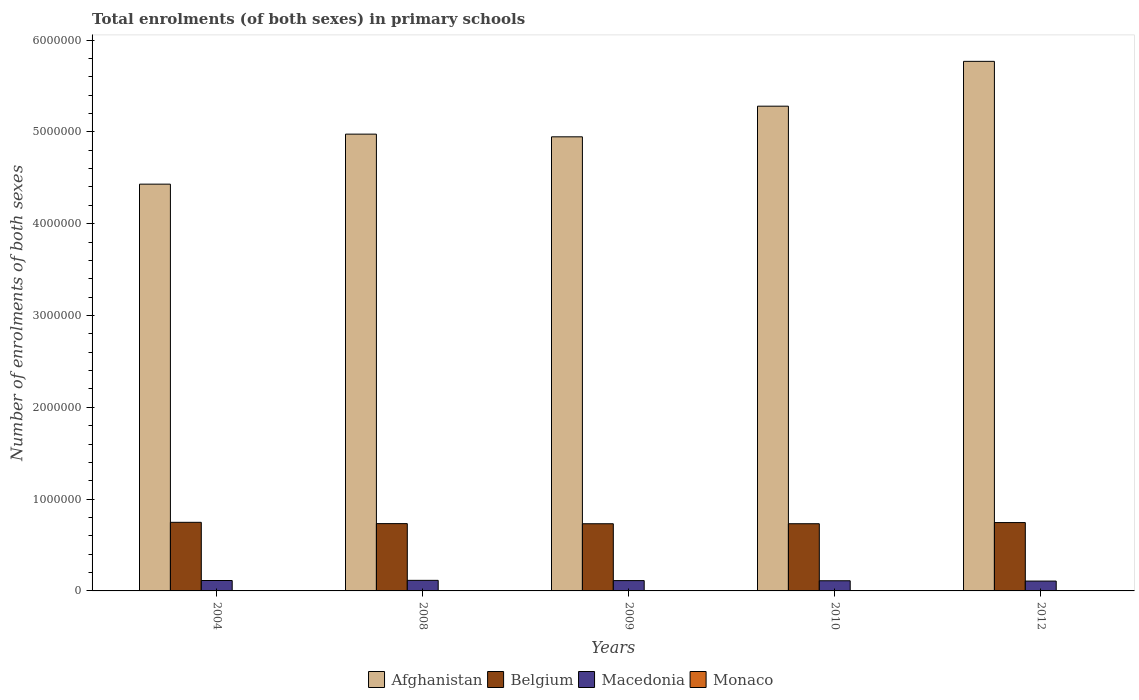How many different coloured bars are there?
Keep it short and to the point. 4. Are the number of bars per tick equal to the number of legend labels?
Provide a short and direct response. Yes. In how many cases, is the number of bars for a given year not equal to the number of legend labels?
Keep it short and to the point. 0. What is the number of enrolments in primary schools in Afghanistan in 2009?
Ensure brevity in your answer.  4.95e+06. Across all years, what is the maximum number of enrolments in primary schools in Afghanistan?
Give a very brief answer. 5.77e+06. Across all years, what is the minimum number of enrolments in primary schools in Belgium?
Offer a very short reply. 7.32e+05. In which year was the number of enrolments in primary schools in Belgium maximum?
Offer a terse response. 2004. What is the total number of enrolments in primary schools in Belgium in the graph?
Your response must be concise. 3.69e+06. What is the difference between the number of enrolments in primary schools in Monaco in 2004 and that in 2012?
Make the answer very short. 65. What is the difference between the number of enrolments in primary schools in Afghanistan in 2009 and the number of enrolments in primary schools in Monaco in 2004?
Offer a terse response. 4.94e+06. What is the average number of enrolments in primary schools in Monaco per year?
Ensure brevity in your answer.  1821.2. In the year 2009, what is the difference between the number of enrolments in primary schools in Monaco and number of enrolments in primary schools in Afghanistan?
Offer a very short reply. -4.94e+06. In how many years, is the number of enrolments in primary schools in Afghanistan greater than 2200000?
Make the answer very short. 5. What is the ratio of the number of enrolments in primary schools in Belgium in 2008 to that in 2009?
Provide a succinct answer. 1. Is the difference between the number of enrolments in primary schools in Monaco in 2008 and 2012 greater than the difference between the number of enrolments in primary schools in Afghanistan in 2008 and 2012?
Your response must be concise. Yes. What is the difference between the highest and the second highest number of enrolments in primary schools in Macedonia?
Make the answer very short. 1720. What is the difference between the highest and the lowest number of enrolments in primary schools in Belgium?
Your response must be concise. 1.55e+04. Is the sum of the number of enrolments in primary schools in Macedonia in 2009 and 2012 greater than the maximum number of enrolments in primary schools in Belgium across all years?
Keep it short and to the point. No. Is it the case that in every year, the sum of the number of enrolments in primary schools in Afghanistan and number of enrolments in primary schools in Belgium is greater than the sum of number of enrolments in primary schools in Macedonia and number of enrolments in primary schools in Monaco?
Offer a terse response. No. What does the 2nd bar from the left in 2009 represents?
Provide a short and direct response. Belgium. What does the 1st bar from the right in 2008 represents?
Provide a short and direct response. Monaco. How many years are there in the graph?
Provide a succinct answer. 5. Are the values on the major ticks of Y-axis written in scientific E-notation?
Provide a succinct answer. No. What is the title of the graph?
Make the answer very short. Total enrolments (of both sexes) in primary schools. What is the label or title of the Y-axis?
Offer a very short reply. Number of enrolments of both sexes. What is the Number of enrolments of both sexes in Afghanistan in 2004?
Your response must be concise. 4.43e+06. What is the Number of enrolments of both sexes in Belgium in 2004?
Your response must be concise. 7.47e+05. What is the Number of enrolments of both sexes of Macedonia in 2004?
Make the answer very short. 1.13e+05. What is the Number of enrolments of both sexes in Monaco in 2004?
Provide a succinct answer. 1831. What is the Number of enrolments of both sexes in Afghanistan in 2008?
Your answer should be compact. 4.97e+06. What is the Number of enrolments of both sexes in Belgium in 2008?
Your answer should be compact. 7.33e+05. What is the Number of enrolments of both sexes in Macedonia in 2008?
Offer a terse response. 1.15e+05. What is the Number of enrolments of both sexes in Monaco in 2008?
Make the answer very short. 1852. What is the Number of enrolments of both sexes of Afghanistan in 2009?
Your answer should be compact. 4.95e+06. What is the Number of enrolments of both sexes in Belgium in 2009?
Make the answer very short. 7.32e+05. What is the Number of enrolments of both sexes in Macedonia in 2009?
Keep it short and to the point. 1.12e+05. What is the Number of enrolments of both sexes of Monaco in 2009?
Offer a terse response. 1837. What is the Number of enrolments of both sexes of Afghanistan in 2010?
Ensure brevity in your answer.  5.28e+06. What is the Number of enrolments of both sexes of Belgium in 2010?
Give a very brief answer. 7.32e+05. What is the Number of enrolments of both sexes of Macedonia in 2010?
Your answer should be compact. 1.11e+05. What is the Number of enrolments of both sexes in Monaco in 2010?
Keep it short and to the point. 1820. What is the Number of enrolments of both sexes of Afghanistan in 2012?
Keep it short and to the point. 5.77e+06. What is the Number of enrolments of both sexes of Belgium in 2012?
Provide a succinct answer. 7.44e+05. What is the Number of enrolments of both sexes of Macedonia in 2012?
Offer a terse response. 1.07e+05. What is the Number of enrolments of both sexes of Monaco in 2012?
Ensure brevity in your answer.  1766. Across all years, what is the maximum Number of enrolments of both sexes of Afghanistan?
Ensure brevity in your answer.  5.77e+06. Across all years, what is the maximum Number of enrolments of both sexes in Belgium?
Provide a short and direct response. 7.47e+05. Across all years, what is the maximum Number of enrolments of both sexes in Macedonia?
Offer a very short reply. 1.15e+05. Across all years, what is the maximum Number of enrolments of both sexes in Monaco?
Your answer should be compact. 1852. Across all years, what is the minimum Number of enrolments of both sexes of Afghanistan?
Your response must be concise. 4.43e+06. Across all years, what is the minimum Number of enrolments of both sexes in Belgium?
Your answer should be compact. 7.32e+05. Across all years, what is the minimum Number of enrolments of both sexes in Macedonia?
Your answer should be compact. 1.07e+05. Across all years, what is the minimum Number of enrolments of both sexes in Monaco?
Offer a terse response. 1766. What is the total Number of enrolments of both sexes of Afghanistan in the graph?
Provide a succinct answer. 2.54e+07. What is the total Number of enrolments of both sexes in Belgium in the graph?
Provide a short and direct response. 3.69e+06. What is the total Number of enrolments of both sexes of Macedonia in the graph?
Offer a terse response. 5.59e+05. What is the total Number of enrolments of both sexes of Monaco in the graph?
Provide a short and direct response. 9106. What is the difference between the Number of enrolments of both sexes of Afghanistan in 2004 and that in 2008?
Make the answer very short. -5.45e+05. What is the difference between the Number of enrolments of both sexes in Belgium in 2004 and that in 2008?
Make the answer very short. 1.41e+04. What is the difference between the Number of enrolments of both sexes of Macedonia in 2004 and that in 2008?
Make the answer very short. -1720. What is the difference between the Number of enrolments of both sexes of Monaco in 2004 and that in 2008?
Your answer should be compact. -21. What is the difference between the Number of enrolments of both sexes of Afghanistan in 2004 and that in 2009?
Ensure brevity in your answer.  -5.15e+05. What is the difference between the Number of enrolments of both sexes of Belgium in 2004 and that in 2009?
Make the answer very short. 1.55e+04. What is the difference between the Number of enrolments of both sexes in Macedonia in 2004 and that in 2009?
Your answer should be compact. 885. What is the difference between the Number of enrolments of both sexes of Afghanistan in 2004 and that in 2010?
Provide a succinct answer. -8.49e+05. What is the difference between the Number of enrolments of both sexes in Belgium in 2004 and that in 2010?
Offer a very short reply. 1.54e+04. What is the difference between the Number of enrolments of both sexes of Macedonia in 2004 and that in 2010?
Give a very brief answer. 2603. What is the difference between the Number of enrolments of both sexes of Monaco in 2004 and that in 2010?
Offer a terse response. 11. What is the difference between the Number of enrolments of both sexes of Afghanistan in 2004 and that in 2012?
Your response must be concise. -1.34e+06. What is the difference between the Number of enrolments of both sexes in Belgium in 2004 and that in 2012?
Give a very brief answer. 2780. What is the difference between the Number of enrolments of both sexes in Macedonia in 2004 and that in 2012?
Give a very brief answer. 6084. What is the difference between the Number of enrolments of both sexes of Monaco in 2004 and that in 2012?
Your answer should be very brief. 65. What is the difference between the Number of enrolments of both sexes in Afghanistan in 2008 and that in 2009?
Your response must be concise. 2.92e+04. What is the difference between the Number of enrolments of both sexes of Belgium in 2008 and that in 2009?
Give a very brief answer. 1449. What is the difference between the Number of enrolments of both sexes of Macedonia in 2008 and that in 2009?
Make the answer very short. 2605. What is the difference between the Number of enrolments of both sexes of Monaco in 2008 and that in 2009?
Make the answer very short. 15. What is the difference between the Number of enrolments of both sexes in Afghanistan in 2008 and that in 2010?
Your response must be concise. -3.04e+05. What is the difference between the Number of enrolments of both sexes of Belgium in 2008 and that in 2010?
Make the answer very short. 1291. What is the difference between the Number of enrolments of both sexes of Macedonia in 2008 and that in 2010?
Your response must be concise. 4323. What is the difference between the Number of enrolments of both sexes of Monaco in 2008 and that in 2010?
Make the answer very short. 32. What is the difference between the Number of enrolments of both sexes of Afghanistan in 2008 and that in 2012?
Keep it short and to the point. -7.93e+05. What is the difference between the Number of enrolments of both sexes in Belgium in 2008 and that in 2012?
Your answer should be very brief. -1.13e+04. What is the difference between the Number of enrolments of both sexes of Macedonia in 2008 and that in 2012?
Your answer should be compact. 7804. What is the difference between the Number of enrolments of both sexes of Monaco in 2008 and that in 2012?
Make the answer very short. 86. What is the difference between the Number of enrolments of both sexes of Afghanistan in 2009 and that in 2010?
Keep it short and to the point. -3.34e+05. What is the difference between the Number of enrolments of both sexes of Belgium in 2009 and that in 2010?
Your response must be concise. -158. What is the difference between the Number of enrolments of both sexes in Macedonia in 2009 and that in 2010?
Offer a very short reply. 1718. What is the difference between the Number of enrolments of both sexes of Afghanistan in 2009 and that in 2012?
Your response must be concise. -8.22e+05. What is the difference between the Number of enrolments of both sexes of Belgium in 2009 and that in 2012?
Your response must be concise. -1.27e+04. What is the difference between the Number of enrolments of both sexes of Macedonia in 2009 and that in 2012?
Offer a very short reply. 5199. What is the difference between the Number of enrolments of both sexes of Afghanistan in 2010 and that in 2012?
Offer a very short reply. -4.88e+05. What is the difference between the Number of enrolments of both sexes in Belgium in 2010 and that in 2012?
Your answer should be compact. -1.26e+04. What is the difference between the Number of enrolments of both sexes of Macedonia in 2010 and that in 2012?
Your response must be concise. 3481. What is the difference between the Number of enrolments of both sexes of Monaco in 2010 and that in 2012?
Your answer should be compact. 54. What is the difference between the Number of enrolments of both sexes of Afghanistan in 2004 and the Number of enrolments of both sexes of Belgium in 2008?
Offer a terse response. 3.70e+06. What is the difference between the Number of enrolments of both sexes of Afghanistan in 2004 and the Number of enrolments of both sexes of Macedonia in 2008?
Keep it short and to the point. 4.32e+06. What is the difference between the Number of enrolments of both sexes of Afghanistan in 2004 and the Number of enrolments of both sexes of Monaco in 2008?
Your answer should be very brief. 4.43e+06. What is the difference between the Number of enrolments of both sexes of Belgium in 2004 and the Number of enrolments of both sexes of Macedonia in 2008?
Provide a short and direct response. 6.32e+05. What is the difference between the Number of enrolments of both sexes of Belgium in 2004 and the Number of enrolments of both sexes of Monaco in 2008?
Ensure brevity in your answer.  7.45e+05. What is the difference between the Number of enrolments of both sexes of Macedonia in 2004 and the Number of enrolments of both sexes of Monaco in 2008?
Provide a short and direct response. 1.12e+05. What is the difference between the Number of enrolments of both sexes in Afghanistan in 2004 and the Number of enrolments of both sexes in Belgium in 2009?
Offer a very short reply. 3.70e+06. What is the difference between the Number of enrolments of both sexes in Afghanistan in 2004 and the Number of enrolments of both sexes in Macedonia in 2009?
Provide a succinct answer. 4.32e+06. What is the difference between the Number of enrolments of both sexes in Afghanistan in 2004 and the Number of enrolments of both sexes in Monaco in 2009?
Give a very brief answer. 4.43e+06. What is the difference between the Number of enrolments of both sexes in Belgium in 2004 and the Number of enrolments of both sexes in Macedonia in 2009?
Make the answer very short. 6.35e+05. What is the difference between the Number of enrolments of both sexes in Belgium in 2004 and the Number of enrolments of both sexes in Monaco in 2009?
Offer a terse response. 7.45e+05. What is the difference between the Number of enrolments of both sexes in Macedonia in 2004 and the Number of enrolments of both sexes in Monaco in 2009?
Offer a very short reply. 1.12e+05. What is the difference between the Number of enrolments of both sexes in Afghanistan in 2004 and the Number of enrolments of both sexes in Belgium in 2010?
Give a very brief answer. 3.70e+06. What is the difference between the Number of enrolments of both sexes of Afghanistan in 2004 and the Number of enrolments of both sexes of Macedonia in 2010?
Provide a succinct answer. 4.32e+06. What is the difference between the Number of enrolments of both sexes of Afghanistan in 2004 and the Number of enrolments of both sexes of Monaco in 2010?
Make the answer very short. 4.43e+06. What is the difference between the Number of enrolments of both sexes in Belgium in 2004 and the Number of enrolments of both sexes in Macedonia in 2010?
Offer a terse response. 6.36e+05. What is the difference between the Number of enrolments of both sexes in Belgium in 2004 and the Number of enrolments of both sexes in Monaco in 2010?
Your response must be concise. 7.45e+05. What is the difference between the Number of enrolments of both sexes in Macedonia in 2004 and the Number of enrolments of both sexes in Monaco in 2010?
Keep it short and to the point. 1.12e+05. What is the difference between the Number of enrolments of both sexes of Afghanistan in 2004 and the Number of enrolments of both sexes of Belgium in 2012?
Make the answer very short. 3.69e+06. What is the difference between the Number of enrolments of both sexes of Afghanistan in 2004 and the Number of enrolments of both sexes of Macedonia in 2012?
Your answer should be compact. 4.32e+06. What is the difference between the Number of enrolments of both sexes of Afghanistan in 2004 and the Number of enrolments of both sexes of Monaco in 2012?
Offer a very short reply. 4.43e+06. What is the difference between the Number of enrolments of both sexes in Belgium in 2004 and the Number of enrolments of both sexes in Macedonia in 2012?
Keep it short and to the point. 6.40e+05. What is the difference between the Number of enrolments of both sexes in Belgium in 2004 and the Number of enrolments of both sexes in Monaco in 2012?
Provide a short and direct response. 7.45e+05. What is the difference between the Number of enrolments of both sexes in Macedonia in 2004 and the Number of enrolments of both sexes in Monaco in 2012?
Your response must be concise. 1.12e+05. What is the difference between the Number of enrolments of both sexes in Afghanistan in 2008 and the Number of enrolments of both sexes in Belgium in 2009?
Your answer should be compact. 4.24e+06. What is the difference between the Number of enrolments of both sexes in Afghanistan in 2008 and the Number of enrolments of both sexes in Macedonia in 2009?
Keep it short and to the point. 4.86e+06. What is the difference between the Number of enrolments of both sexes of Afghanistan in 2008 and the Number of enrolments of both sexes of Monaco in 2009?
Provide a succinct answer. 4.97e+06. What is the difference between the Number of enrolments of both sexes in Belgium in 2008 and the Number of enrolments of both sexes in Macedonia in 2009?
Ensure brevity in your answer.  6.21e+05. What is the difference between the Number of enrolments of both sexes of Belgium in 2008 and the Number of enrolments of both sexes of Monaco in 2009?
Offer a terse response. 7.31e+05. What is the difference between the Number of enrolments of both sexes in Macedonia in 2008 and the Number of enrolments of both sexes in Monaco in 2009?
Your answer should be compact. 1.13e+05. What is the difference between the Number of enrolments of both sexes of Afghanistan in 2008 and the Number of enrolments of both sexes of Belgium in 2010?
Your answer should be very brief. 4.24e+06. What is the difference between the Number of enrolments of both sexes of Afghanistan in 2008 and the Number of enrolments of both sexes of Macedonia in 2010?
Your response must be concise. 4.86e+06. What is the difference between the Number of enrolments of both sexes in Afghanistan in 2008 and the Number of enrolments of both sexes in Monaco in 2010?
Make the answer very short. 4.97e+06. What is the difference between the Number of enrolments of both sexes in Belgium in 2008 and the Number of enrolments of both sexes in Macedonia in 2010?
Provide a succinct answer. 6.22e+05. What is the difference between the Number of enrolments of both sexes of Belgium in 2008 and the Number of enrolments of both sexes of Monaco in 2010?
Your answer should be compact. 7.31e+05. What is the difference between the Number of enrolments of both sexes of Macedonia in 2008 and the Number of enrolments of both sexes of Monaco in 2010?
Your answer should be very brief. 1.13e+05. What is the difference between the Number of enrolments of both sexes in Afghanistan in 2008 and the Number of enrolments of both sexes in Belgium in 2012?
Keep it short and to the point. 4.23e+06. What is the difference between the Number of enrolments of both sexes of Afghanistan in 2008 and the Number of enrolments of both sexes of Macedonia in 2012?
Keep it short and to the point. 4.87e+06. What is the difference between the Number of enrolments of both sexes in Afghanistan in 2008 and the Number of enrolments of both sexes in Monaco in 2012?
Your answer should be compact. 4.97e+06. What is the difference between the Number of enrolments of both sexes in Belgium in 2008 and the Number of enrolments of both sexes in Macedonia in 2012?
Offer a terse response. 6.26e+05. What is the difference between the Number of enrolments of both sexes in Belgium in 2008 and the Number of enrolments of both sexes in Monaco in 2012?
Your answer should be compact. 7.31e+05. What is the difference between the Number of enrolments of both sexes of Macedonia in 2008 and the Number of enrolments of both sexes of Monaco in 2012?
Give a very brief answer. 1.13e+05. What is the difference between the Number of enrolments of both sexes in Afghanistan in 2009 and the Number of enrolments of both sexes in Belgium in 2010?
Your answer should be compact. 4.21e+06. What is the difference between the Number of enrolments of both sexes of Afghanistan in 2009 and the Number of enrolments of both sexes of Macedonia in 2010?
Offer a very short reply. 4.83e+06. What is the difference between the Number of enrolments of both sexes in Afghanistan in 2009 and the Number of enrolments of both sexes in Monaco in 2010?
Provide a short and direct response. 4.94e+06. What is the difference between the Number of enrolments of both sexes in Belgium in 2009 and the Number of enrolments of both sexes in Macedonia in 2010?
Make the answer very short. 6.21e+05. What is the difference between the Number of enrolments of both sexes of Belgium in 2009 and the Number of enrolments of both sexes of Monaco in 2010?
Ensure brevity in your answer.  7.30e+05. What is the difference between the Number of enrolments of both sexes in Macedonia in 2009 and the Number of enrolments of both sexes in Monaco in 2010?
Keep it short and to the point. 1.11e+05. What is the difference between the Number of enrolments of both sexes of Afghanistan in 2009 and the Number of enrolments of both sexes of Belgium in 2012?
Make the answer very short. 4.20e+06. What is the difference between the Number of enrolments of both sexes of Afghanistan in 2009 and the Number of enrolments of both sexes of Macedonia in 2012?
Your response must be concise. 4.84e+06. What is the difference between the Number of enrolments of both sexes of Afghanistan in 2009 and the Number of enrolments of both sexes of Monaco in 2012?
Provide a succinct answer. 4.94e+06. What is the difference between the Number of enrolments of both sexes in Belgium in 2009 and the Number of enrolments of both sexes in Macedonia in 2012?
Provide a short and direct response. 6.24e+05. What is the difference between the Number of enrolments of both sexes in Belgium in 2009 and the Number of enrolments of both sexes in Monaco in 2012?
Offer a terse response. 7.30e+05. What is the difference between the Number of enrolments of both sexes in Macedonia in 2009 and the Number of enrolments of both sexes in Monaco in 2012?
Make the answer very short. 1.11e+05. What is the difference between the Number of enrolments of both sexes in Afghanistan in 2010 and the Number of enrolments of both sexes in Belgium in 2012?
Your answer should be very brief. 4.53e+06. What is the difference between the Number of enrolments of both sexes of Afghanistan in 2010 and the Number of enrolments of both sexes of Macedonia in 2012?
Offer a terse response. 5.17e+06. What is the difference between the Number of enrolments of both sexes of Afghanistan in 2010 and the Number of enrolments of both sexes of Monaco in 2012?
Provide a short and direct response. 5.28e+06. What is the difference between the Number of enrolments of both sexes of Belgium in 2010 and the Number of enrolments of both sexes of Macedonia in 2012?
Ensure brevity in your answer.  6.24e+05. What is the difference between the Number of enrolments of both sexes of Belgium in 2010 and the Number of enrolments of both sexes of Monaco in 2012?
Provide a succinct answer. 7.30e+05. What is the difference between the Number of enrolments of both sexes in Macedonia in 2010 and the Number of enrolments of both sexes in Monaco in 2012?
Ensure brevity in your answer.  1.09e+05. What is the average Number of enrolments of both sexes in Afghanistan per year?
Your answer should be very brief. 5.08e+06. What is the average Number of enrolments of both sexes of Belgium per year?
Provide a succinct answer. 7.38e+05. What is the average Number of enrolments of both sexes in Macedonia per year?
Your answer should be compact. 1.12e+05. What is the average Number of enrolments of both sexes in Monaco per year?
Provide a succinct answer. 1821.2. In the year 2004, what is the difference between the Number of enrolments of both sexes in Afghanistan and Number of enrolments of both sexes in Belgium?
Make the answer very short. 3.68e+06. In the year 2004, what is the difference between the Number of enrolments of both sexes of Afghanistan and Number of enrolments of both sexes of Macedonia?
Offer a very short reply. 4.32e+06. In the year 2004, what is the difference between the Number of enrolments of both sexes in Afghanistan and Number of enrolments of both sexes in Monaco?
Give a very brief answer. 4.43e+06. In the year 2004, what is the difference between the Number of enrolments of both sexes of Belgium and Number of enrolments of both sexes of Macedonia?
Provide a succinct answer. 6.34e+05. In the year 2004, what is the difference between the Number of enrolments of both sexes of Belgium and Number of enrolments of both sexes of Monaco?
Your answer should be compact. 7.45e+05. In the year 2004, what is the difference between the Number of enrolments of both sexes of Macedonia and Number of enrolments of both sexes of Monaco?
Your response must be concise. 1.12e+05. In the year 2008, what is the difference between the Number of enrolments of both sexes in Afghanistan and Number of enrolments of both sexes in Belgium?
Keep it short and to the point. 4.24e+06. In the year 2008, what is the difference between the Number of enrolments of both sexes in Afghanistan and Number of enrolments of both sexes in Macedonia?
Your answer should be very brief. 4.86e+06. In the year 2008, what is the difference between the Number of enrolments of both sexes of Afghanistan and Number of enrolments of both sexes of Monaco?
Your answer should be compact. 4.97e+06. In the year 2008, what is the difference between the Number of enrolments of both sexes in Belgium and Number of enrolments of both sexes in Macedonia?
Keep it short and to the point. 6.18e+05. In the year 2008, what is the difference between the Number of enrolments of both sexes in Belgium and Number of enrolments of both sexes in Monaco?
Give a very brief answer. 7.31e+05. In the year 2008, what is the difference between the Number of enrolments of both sexes of Macedonia and Number of enrolments of both sexes of Monaco?
Offer a terse response. 1.13e+05. In the year 2009, what is the difference between the Number of enrolments of both sexes in Afghanistan and Number of enrolments of both sexes in Belgium?
Your response must be concise. 4.21e+06. In the year 2009, what is the difference between the Number of enrolments of both sexes in Afghanistan and Number of enrolments of both sexes in Macedonia?
Make the answer very short. 4.83e+06. In the year 2009, what is the difference between the Number of enrolments of both sexes of Afghanistan and Number of enrolments of both sexes of Monaco?
Ensure brevity in your answer.  4.94e+06. In the year 2009, what is the difference between the Number of enrolments of both sexes of Belgium and Number of enrolments of both sexes of Macedonia?
Offer a terse response. 6.19e+05. In the year 2009, what is the difference between the Number of enrolments of both sexes of Belgium and Number of enrolments of both sexes of Monaco?
Provide a succinct answer. 7.30e+05. In the year 2009, what is the difference between the Number of enrolments of both sexes of Macedonia and Number of enrolments of both sexes of Monaco?
Your answer should be compact. 1.11e+05. In the year 2010, what is the difference between the Number of enrolments of both sexes in Afghanistan and Number of enrolments of both sexes in Belgium?
Ensure brevity in your answer.  4.55e+06. In the year 2010, what is the difference between the Number of enrolments of both sexes in Afghanistan and Number of enrolments of both sexes in Macedonia?
Make the answer very short. 5.17e+06. In the year 2010, what is the difference between the Number of enrolments of both sexes in Afghanistan and Number of enrolments of both sexes in Monaco?
Your response must be concise. 5.28e+06. In the year 2010, what is the difference between the Number of enrolments of both sexes in Belgium and Number of enrolments of both sexes in Macedonia?
Provide a succinct answer. 6.21e+05. In the year 2010, what is the difference between the Number of enrolments of both sexes in Belgium and Number of enrolments of both sexes in Monaco?
Your answer should be compact. 7.30e+05. In the year 2010, what is the difference between the Number of enrolments of both sexes in Macedonia and Number of enrolments of both sexes in Monaco?
Provide a succinct answer. 1.09e+05. In the year 2012, what is the difference between the Number of enrolments of both sexes of Afghanistan and Number of enrolments of both sexes of Belgium?
Ensure brevity in your answer.  5.02e+06. In the year 2012, what is the difference between the Number of enrolments of both sexes of Afghanistan and Number of enrolments of both sexes of Macedonia?
Provide a succinct answer. 5.66e+06. In the year 2012, what is the difference between the Number of enrolments of both sexes of Afghanistan and Number of enrolments of both sexes of Monaco?
Keep it short and to the point. 5.77e+06. In the year 2012, what is the difference between the Number of enrolments of both sexes of Belgium and Number of enrolments of both sexes of Macedonia?
Provide a succinct answer. 6.37e+05. In the year 2012, what is the difference between the Number of enrolments of both sexes of Belgium and Number of enrolments of both sexes of Monaco?
Your answer should be compact. 7.43e+05. In the year 2012, what is the difference between the Number of enrolments of both sexes of Macedonia and Number of enrolments of both sexes of Monaco?
Provide a succinct answer. 1.06e+05. What is the ratio of the Number of enrolments of both sexes of Afghanistan in 2004 to that in 2008?
Your response must be concise. 0.89. What is the ratio of the Number of enrolments of both sexes in Belgium in 2004 to that in 2008?
Keep it short and to the point. 1.02. What is the ratio of the Number of enrolments of both sexes of Macedonia in 2004 to that in 2008?
Keep it short and to the point. 0.99. What is the ratio of the Number of enrolments of both sexes in Monaco in 2004 to that in 2008?
Your answer should be compact. 0.99. What is the ratio of the Number of enrolments of both sexes in Afghanistan in 2004 to that in 2009?
Your answer should be compact. 0.9. What is the ratio of the Number of enrolments of both sexes of Belgium in 2004 to that in 2009?
Provide a short and direct response. 1.02. What is the ratio of the Number of enrolments of both sexes in Macedonia in 2004 to that in 2009?
Your answer should be compact. 1.01. What is the ratio of the Number of enrolments of both sexes of Monaco in 2004 to that in 2009?
Ensure brevity in your answer.  1. What is the ratio of the Number of enrolments of both sexes of Afghanistan in 2004 to that in 2010?
Provide a succinct answer. 0.84. What is the ratio of the Number of enrolments of both sexes of Macedonia in 2004 to that in 2010?
Keep it short and to the point. 1.02. What is the ratio of the Number of enrolments of both sexes in Afghanistan in 2004 to that in 2012?
Make the answer very short. 0.77. What is the ratio of the Number of enrolments of both sexes of Belgium in 2004 to that in 2012?
Your answer should be very brief. 1. What is the ratio of the Number of enrolments of both sexes of Macedonia in 2004 to that in 2012?
Your response must be concise. 1.06. What is the ratio of the Number of enrolments of both sexes of Monaco in 2004 to that in 2012?
Ensure brevity in your answer.  1.04. What is the ratio of the Number of enrolments of both sexes in Afghanistan in 2008 to that in 2009?
Provide a short and direct response. 1.01. What is the ratio of the Number of enrolments of both sexes of Belgium in 2008 to that in 2009?
Your answer should be very brief. 1. What is the ratio of the Number of enrolments of both sexes in Macedonia in 2008 to that in 2009?
Offer a terse response. 1.02. What is the ratio of the Number of enrolments of both sexes of Monaco in 2008 to that in 2009?
Ensure brevity in your answer.  1.01. What is the ratio of the Number of enrolments of both sexes of Afghanistan in 2008 to that in 2010?
Provide a short and direct response. 0.94. What is the ratio of the Number of enrolments of both sexes of Macedonia in 2008 to that in 2010?
Keep it short and to the point. 1.04. What is the ratio of the Number of enrolments of both sexes in Monaco in 2008 to that in 2010?
Make the answer very short. 1.02. What is the ratio of the Number of enrolments of both sexes in Afghanistan in 2008 to that in 2012?
Your answer should be very brief. 0.86. What is the ratio of the Number of enrolments of both sexes of Macedonia in 2008 to that in 2012?
Offer a terse response. 1.07. What is the ratio of the Number of enrolments of both sexes in Monaco in 2008 to that in 2012?
Offer a terse response. 1.05. What is the ratio of the Number of enrolments of both sexes of Afghanistan in 2009 to that in 2010?
Offer a very short reply. 0.94. What is the ratio of the Number of enrolments of both sexes of Belgium in 2009 to that in 2010?
Your response must be concise. 1. What is the ratio of the Number of enrolments of both sexes of Macedonia in 2009 to that in 2010?
Your answer should be very brief. 1.02. What is the ratio of the Number of enrolments of both sexes of Monaco in 2009 to that in 2010?
Make the answer very short. 1.01. What is the ratio of the Number of enrolments of both sexes of Afghanistan in 2009 to that in 2012?
Provide a succinct answer. 0.86. What is the ratio of the Number of enrolments of both sexes of Belgium in 2009 to that in 2012?
Offer a very short reply. 0.98. What is the ratio of the Number of enrolments of both sexes in Macedonia in 2009 to that in 2012?
Give a very brief answer. 1.05. What is the ratio of the Number of enrolments of both sexes in Monaco in 2009 to that in 2012?
Your answer should be very brief. 1.04. What is the ratio of the Number of enrolments of both sexes of Afghanistan in 2010 to that in 2012?
Give a very brief answer. 0.92. What is the ratio of the Number of enrolments of both sexes in Belgium in 2010 to that in 2012?
Give a very brief answer. 0.98. What is the ratio of the Number of enrolments of both sexes of Macedonia in 2010 to that in 2012?
Provide a succinct answer. 1.03. What is the ratio of the Number of enrolments of both sexes of Monaco in 2010 to that in 2012?
Ensure brevity in your answer.  1.03. What is the difference between the highest and the second highest Number of enrolments of both sexes of Afghanistan?
Offer a terse response. 4.88e+05. What is the difference between the highest and the second highest Number of enrolments of both sexes in Belgium?
Offer a terse response. 2780. What is the difference between the highest and the second highest Number of enrolments of both sexes of Macedonia?
Give a very brief answer. 1720. What is the difference between the highest and the second highest Number of enrolments of both sexes of Monaco?
Ensure brevity in your answer.  15. What is the difference between the highest and the lowest Number of enrolments of both sexes in Afghanistan?
Provide a succinct answer. 1.34e+06. What is the difference between the highest and the lowest Number of enrolments of both sexes of Belgium?
Offer a very short reply. 1.55e+04. What is the difference between the highest and the lowest Number of enrolments of both sexes of Macedonia?
Your answer should be very brief. 7804. What is the difference between the highest and the lowest Number of enrolments of both sexes of Monaco?
Provide a succinct answer. 86. 